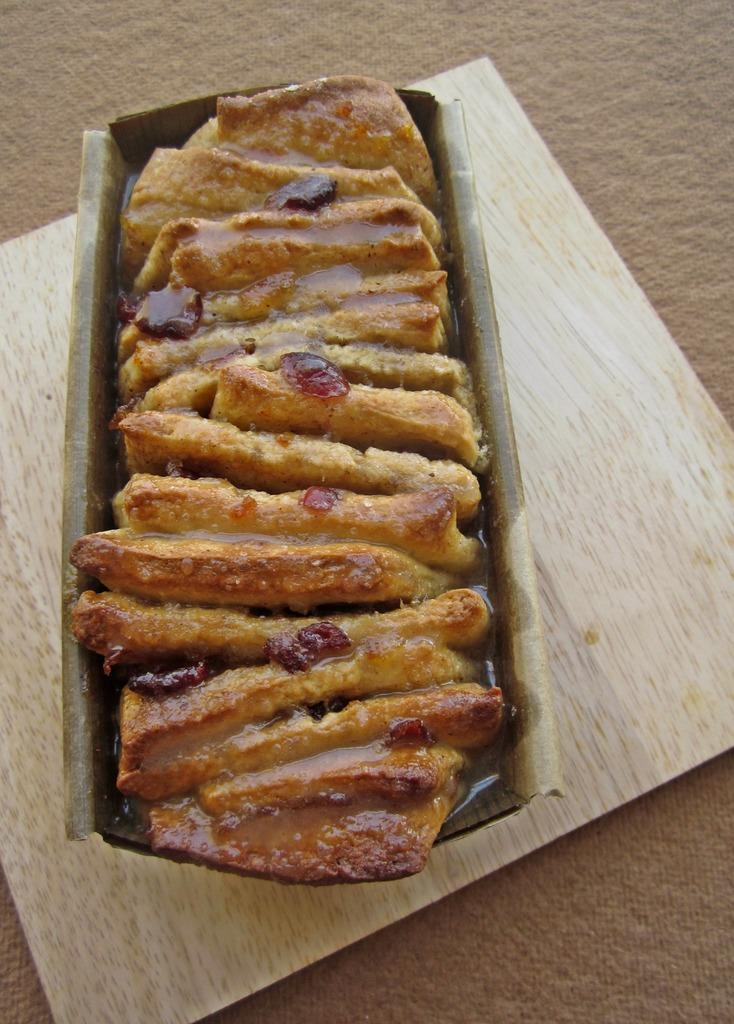What is inside the container in the image? The container holds a food item. Where is the container located in the image? The container is placed on a wooden square sheet. What is the color of the wooden sheet's surface? The surface of the wooden sheet is pale brown in color. What type of government is depicted in the image? There is no depiction of a government in the image; it features a container with a food item on a wooden square sheet. 